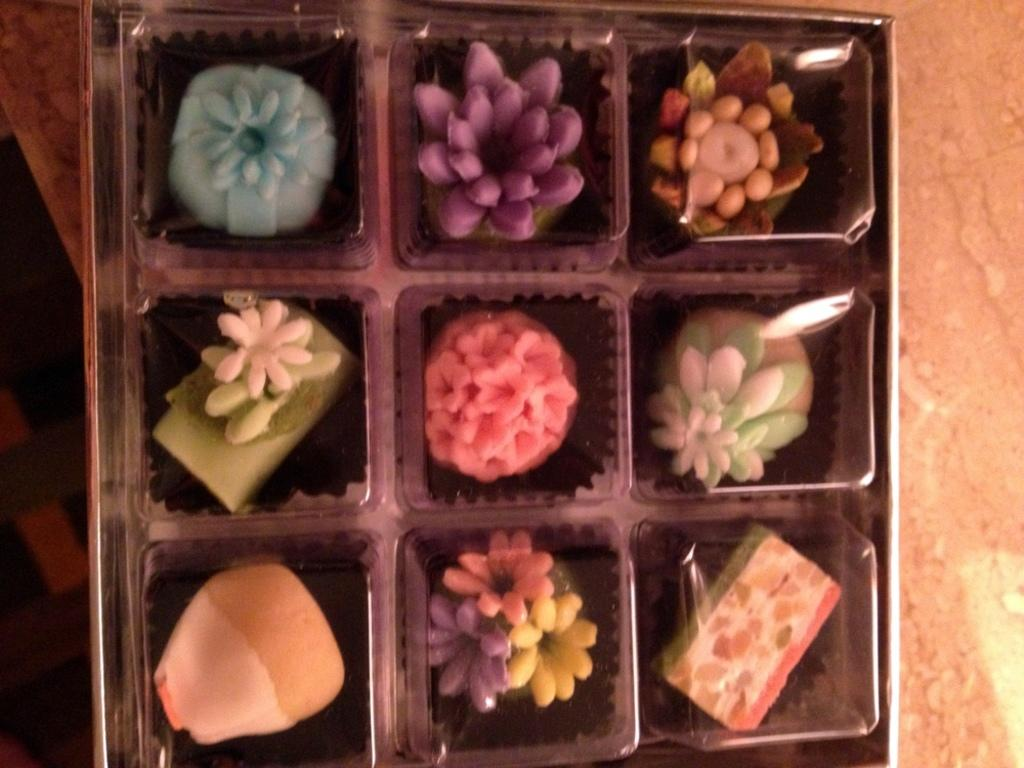What type of food items are present in the image? There are sweets in the image. How are the sweets contained or organized in the image? The sweets are in a box. Where is the box with sweets located? The box is on a table. What type of salt is stored in the tin next to the sweets in the image? There is no tin or salt present in the image; it only features sweets in a box on a table. 